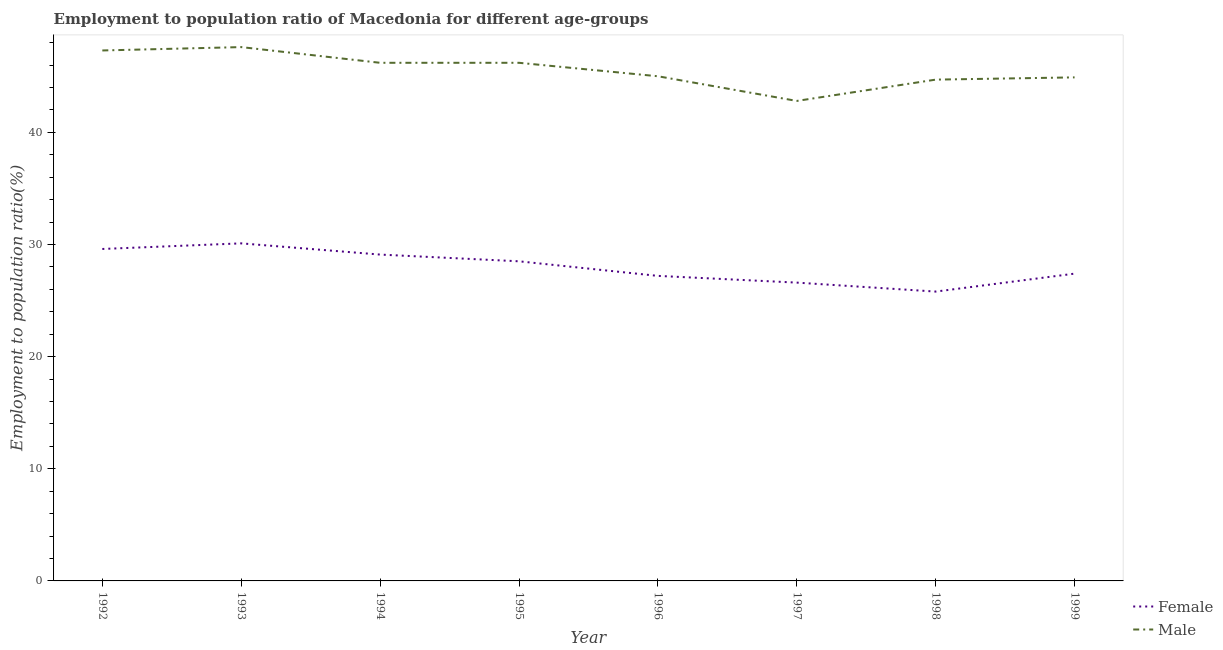How many different coloured lines are there?
Your answer should be very brief. 2. Does the line corresponding to employment to population ratio(female) intersect with the line corresponding to employment to population ratio(male)?
Your answer should be compact. No. Is the number of lines equal to the number of legend labels?
Give a very brief answer. Yes. What is the employment to population ratio(female) in 1992?
Your answer should be very brief. 29.6. Across all years, what is the maximum employment to population ratio(male)?
Provide a short and direct response. 47.6. Across all years, what is the minimum employment to population ratio(female)?
Provide a short and direct response. 25.8. In which year was the employment to population ratio(male) maximum?
Your response must be concise. 1993. In which year was the employment to population ratio(male) minimum?
Your answer should be very brief. 1997. What is the total employment to population ratio(male) in the graph?
Provide a succinct answer. 364.7. What is the difference between the employment to population ratio(male) in 1993 and that in 1997?
Your response must be concise. 4.8. What is the difference between the employment to population ratio(male) in 1997 and the employment to population ratio(female) in 1995?
Keep it short and to the point. 14.3. What is the average employment to population ratio(male) per year?
Your response must be concise. 45.59. In the year 1993, what is the difference between the employment to population ratio(female) and employment to population ratio(male)?
Offer a terse response. -17.5. What is the ratio of the employment to population ratio(male) in 1994 to that in 1996?
Your answer should be very brief. 1.03. Is the employment to population ratio(female) in 1992 less than that in 1999?
Provide a succinct answer. No. What is the difference between the highest and the second highest employment to population ratio(male)?
Your response must be concise. 0.3. What is the difference between the highest and the lowest employment to population ratio(male)?
Your answer should be compact. 4.8. Does the employment to population ratio(female) monotonically increase over the years?
Make the answer very short. No. Is the employment to population ratio(male) strictly greater than the employment to population ratio(female) over the years?
Offer a terse response. Yes. Is the employment to population ratio(male) strictly less than the employment to population ratio(female) over the years?
Offer a very short reply. No. How many lines are there?
Your response must be concise. 2. How many years are there in the graph?
Offer a very short reply. 8. Are the values on the major ticks of Y-axis written in scientific E-notation?
Keep it short and to the point. No. Where does the legend appear in the graph?
Provide a short and direct response. Bottom right. How many legend labels are there?
Give a very brief answer. 2. What is the title of the graph?
Make the answer very short. Employment to population ratio of Macedonia for different age-groups. What is the label or title of the X-axis?
Provide a short and direct response. Year. What is the Employment to population ratio(%) in Female in 1992?
Your answer should be compact. 29.6. What is the Employment to population ratio(%) in Male in 1992?
Provide a short and direct response. 47.3. What is the Employment to population ratio(%) in Female in 1993?
Ensure brevity in your answer.  30.1. What is the Employment to population ratio(%) of Male in 1993?
Make the answer very short. 47.6. What is the Employment to population ratio(%) of Female in 1994?
Your response must be concise. 29.1. What is the Employment to population ratio(%) in Male in 1994?
Your answer should be compact. 46.2. What is the Employment to population ratio(%) in Female in 1995?
Offer a very short reply. 28.5. What is the Employment to population ratio(%) of Male in 1995?
Provide a short and direct response. 46.2. What is the Employment to population ratio(%) in Female in 1996?
Your response must be concise. 27.2. What is the Employment to population ratio(%) in Male in 1996?
Provide a succinct answer. 45. What is the Employment to population ratio(%) of Female in 1997?
Make the answer very short. 26.6. What is the Employment to population ratio(%) of Male in 1997?
Provide a short and direct response. 42.8. What is the Employment to population ratio(%) in Female in 1998?
Your answer should be compact. 25.8. What is the Employment to population ratio(%) in Male in 1998?
Your response must be concise. 44.7. What is the Employment to population ratio(%) of Female in 1999?
Give a very brief answer. 27.4. What is the Employment to population ratio(%) of Male in 1999?
Ensure brevity in your answer.  44.9. Across all years, what is the maximum Employment to population ratio(%) of Female?
Your answer should be very brief. 30.1. Across all years, what is the maximum Employment to population ratio(%) in Male?
Make the answer very short. 47.6. Across all years, what is the minimum Employment to population ratio(%) of Female?
Keep it short and to the point. 25.8. Across all years, what is the minimum Employment to population ratio(%) in Male?
Your answer should be very brief. 42.8. What is the total Employment to population ratio(%) in Female in the graph?
Ensure brevity in your answer.  224.3. What is the total Employment to population ratio(%) of Male in the graph?
Keep it short and to the point. 364.7. What is the difference between the Employment to population ratio(%) of Male in 1992 and that in 1993?
Your response must be concise. -0.3. What is the difference between the Employment to population ratio(%) of Male in 1992 and that in 1995?
Your answer should be very brief. 1.1. What is the difference between the Employment to population ratio(%) of Male in 1992 and that in 1996?
Your answer should be very brief. 2.3. What is the difference between the Employment to population ratio(%) of Female in 1992 and that in 1997?
Offer a terse response. 3. What is the difference between the Employment to population ratio(%) of Female in 1992 and that in 1998?
Keep it short and to the point. 3.8. What is the difference between the Employment to population ratio(%) of Female in 1992 and that in 1999?
Keep it short and to the point. 2.2. What is the difference between the Employment to population ratio(%) in Male in 1992 and that in 1999?
Your answer should be compact. 2.4. What is the difference between the Employment to population ratio(%) of Male in 1993 and that in 1995?
Make the answer very short. 1.4. What is the difference between the Employment to population ratio(%) of Female in 1993 and that in 1996?
Make the answer very short. 2.9. What is the difference between the Employment to population ratio(%) of Male in 1993 and that in 1996?
Keep it short and to the point. 2.6. What is the difference between the Employment to population ratio(%) in Male in 1993 and that in 1997?
Your response must be concise. 4.8. What is the difference between the Employment to population ratio(%) of Female in 1993 and that in 1999?
Your response must be concise. 2.7. What is the difference between the Employment to population ratio(%) of Male in 1993 and that in 1999?
Make the answer very short. 2.7. What is the difference between the Employment to population ratio(%) of Male in 1994 and that in 1996?
Provide a short and direct response. 1.2. What is the difference between the Employment to population ratio(%) of Female in 1994 and that in 1997?
Make the answer very short. 2.5. What is the difference between the Employment to population ratio(%) of Female in 1994 and that in 1998?
Give a very brief answer. 3.3. What is the difference between the Employment to population ratio(%) in Female in 1995 and that in 1996?
Your response must be concise. 1.3. What is the difference between the Employment to population ratio(%) in Male in 1995 and that in 1998?
Make the answer very short. 1.5. What is the difference between the Employment to population ratio(%) in Male in 1995 and that in 1999?
Offer a terse response. 1.3. What is the difference between the Employment to population ratio(%) of Female in 1996 and that in 1997?
Make the answer very short. 0.6. What is the difference between the Employment to population ratio(%) in Male in 1996 and that in 1998?
Your answer should be very brief. 0.3. What is the difference between the Employment to population ratio(%) of Male in 1996 and that in 1999?
Your answer should be very brief. 0.1. What is the difference between the Employment to population ratio(%) in Male in 1997 and that in 1999?
Ensure brevity in your answer.  -2.1. What is the difference between the Employment to population ratio(%) in Female in 1992 and the Employment to population ratio(%) in Male in 1993?
Keep it short and to the point. -18. What is the difference between the Employment to population ratio(%) in Female in 1992 and the Employment to population ratio(%) in Male in 1994?
Your answer should be very brief. -16.6. What is the difference between the Employment to population ratio(%) of Female in 1992 and the Employment to population ratio(%) of Male in 1995?
Your response must be concise. -16.6. What is the difference between the Employment to population ratio(%) of Female in 1992 and the Employment to population ratio(%) of Male in 1996?
Keep it short and to the point. -15.4. What is the difference between the Employment to population ratio(%) of Female in 1992 and the Employment to population ratio(%) of Male in 1997?
Provide a short and direct response. -13.2. What is the difference between the Employment to population ratio(%) in Female in 1992 and the Employment to population ratio(%) in Male in 1998?
Your response must be concise. -15.1. What is the difference between the Employment to population ratio(%) in Female in 1992 and the Employment to population ratio(%) in Male in 1999?
Give a very brief answer. -15.3. What is the difference between the Employment to population ratio(%) in Female in 1993 and the Employment to population ratio(%) in Male in 1994?
Make the answer very short. -16.1. What is the difference between the Employment to population ratio(%) of Female in 1993 and the Employment to population ratio(%) of Male in 1995?
Offer a terse response. -16.1. What is the difference between the Employment to population ratio(%) of Female in 1993 and the Employment to population ratio(%) of Male in 1996?
Ensure brevity in your answer.  -14.9. What is the difference between the Employment to population ratio(%) in Female in 1993 and the Employment to population ratio(%) in Male in 1997?
Your answer should be compact. -12.7. What is the difference between the Employment to population ratio(%) in Female in 1993 and the Employment to population ratio(%) in Male in 1998?
Your answer should be compact. -14.6. What is the difference between the Employment to population ratio(%) of Female in 1993 and the Employment to population ratio(%) of Male in 1999?
Ensure brevity in your answer.  -14.8. What is the difference between the Employment to population ratio(%) in Female in 1994 and the Employment to population ratio(%) in Male in 1995?
Provide a succinct answer. -17.1. What is the difference between the Employment to population ratio(%) in Female in 1994 and the Employment to population ratio(%) in Male in 1996?
Ensure brevity in your answer.  -15.9. What is the difference between the Employment to population ratio(%) of Female in 1994 and the Employment to population ratio(%) of Male in 1997?
Your answer should be very brief. -13.7. What is the difference between the Employment to population ratio(%) in Female in 1994 and the Employment to population ratio(%) in Male in 1998?
Keep it short and to the point. -15.6. What is the difference between the Employment to population ratio(%) of Female in 1994 and the Employment to population ratio(%) of Male in 1999?
Your answer should be very brief. -15.8. What is the difference between the Employment to population ratio(%) of Female in 1995 and the Employment to population ratio(%) of Male in 1996?
Give a very brief answer. -16.5. What is the difference between the Employment to population ratio(%) in Female in 1995 and the Employment to population ratio(%) in Male in 1997?
Provide a succinct answer. -14.3. What is the difference between the Employment to population ratio(%) in Female in 1995 and the Employment to population ratio(%) in Male in 1998?
Make the answer very short. -16.2. What is the difference between the Employment to population ratio(%) of Female in 1995 and the Employment to population ratio(%) of Male in 1999?
Your answer should be very brief. -16.4. What is the difference between the Employment to population ratio(%) in Female in 1996 and the Employment to population ratio(%) in Male in 1997?
Your response must be concise. -15.6. What is the difference between the Employment to population ratio(%) in Female in 1996 and the Employment to population ratio(%) in Male in 1998?
Keep it short and to the point. -17.5. What is the difference between the Employment to population ratio(%) in Female in 1996 and the Employment to population ratio(%) in Male in 1999?
Provide a succinct answer. -17.7. What is the difference between the Employment to population ratio(%) of Female in 1997 and the Employment to population ratio(%) of Male in 1998?
Your answer should be very brief. -18.1. What is the difference between the Employment to population ratio(%) in Female in 1997 and the Employment to population ratio(%) in Male in 1999?
Offer a terse response. -18.3. What is the difference between the Employment to population ratio(%) of Female in 1998 and the Employment to population ratio(%) of Male in 1999?
Provide a short and direct response. -19.1. What is the average Employment to population ratio(%) of Female per year?
Provide a succinct answer. 28.04. What is the average Employment to population ratio(%) of Male per year?
Make the answer very short. 45.59. In the year 1992, what is the difference between the Employment to population ratio(%) of Female and Employment to population ratio(%) of Male?
Your answer should be very brief. -17.7. In the year 1993, what is the difference between the Employment to population ratio(%) in Female and Employment to population ratio(%) in Male?
Offer a terse response. -17.5. In the year 1994, what is the difference between the Employment to population ratio(%) of Female and Employment to population ratio(%) of Male?
Make the answer very short. -17.1. In the year 1995, what is the difference between the Employment to population ratio(%) of Female and Employment to population ratio(%) of Male?
Ensure brevity in your answer.  -17.7. In the year 1996, what is the difference between the Employment to population ratio(%) of Female and Employment to population ratio(%) of Male?
Provide a succinct answer. -17.8. In the year 1997, what is the difference between the Employment to population ratio(%) in Female and Employment to population ratio(%) in Male?
Your response must be concise. -16.2. In the year 1998, what is the difference between the Employment to population ratio(%) of Female and Employment to population ratio(%) of Male?
Provide a short and direct response. -18.9. In the year 1999, what is the difference between the Employment to population ratio(%) in Female and Employment to population ratio(%) in Male?
Offer a very short reply. -17.5. What is the ratio of the Employment to population ratio(%) in Female in 1992 to that in 1993?
Your answer should be very brief. 0.98. What is the ratio of the Employment to population ratio(%) in Female in 1992 to that in 1994?
Your response must be concise. 1.02. What is the ratio of the Employment to population ratio(%) of Male in 1992 to that in 1994?
Your response must be concise. 1.02. What is the ratio of the Employment to population ratio(%) in Female in 1992 to that in 1995?
Your response must be concise. 1.04. What is the ratio of the Employment to population ratio(%) of Male in 1992 to that in 1995?
Provide a succinct answer. 1.02. What is the ratio of the Employment to population ratio(%) in Female in 1992 to that in 1996?
Offer a terse response. 1.09. What is the ratio of the Employment to population ratio(%) of Male in 1992 to that in 1996?
Provide a succinct answer. 1.05. What is the ratio of the Employment to population ratio(%) in Female in 1992 to that in 1997?
Your response must be concise. 1.11. What is the ratio of the Employment to population ratio(%) in Male in 1992 to that in 1997?
Provide a succinct answer. 1.11. What is the ratio of the Employment to population ratio(%) in Female in 1992 to that in 1998?
Your answer should be very brief. 1.15. What is the ratio of the Employment to population ratio(%) of Male in 1992 to that in 1998?
Offer a terse response. 1.06. What is the ratio of the Employment to population ratio(%) of Female in 1992 to that in 1999?
Offer a terse response. 1.08. What is the ratio of the Employment to population ratio(%) of Male in 1992 to that in 1999?
Make the answer very short. 1.05. What is the ratio of the Employment to population ratio(%) of Female in 1993 to that in 1994?
Offer a terse response. 1.03. What is the ratio of the Employment to population ratio(%) in Male in 1993 to that in 1994?
Make the answer very short. 1.03. What is the ratio of the Employment to population ratio(%) of Female in 1993 to that in 1995?
Ensure brevity in your answer.  1.06. What is the ratio of the Employment to population ratio(%) in Male in 1993 to that in 1995?
Ensure brevity in your answer.  1.03. What is the ratio of the Employment to population ratio(%) in Female in 1993 to that in 1996?
Keep it short and to the point. 1.11. What is the ratio of the Employment to population ratio(%) in Male in 1993 to that in 1996?
Ensure brevity in your answer.  1.06. What is the ratio of the Employment to population ratio(%) in Female in 1993 to that in 1997?
Your response must be concise. 1.13. What is the ratio of the Employment to population ratio(%) in Male in 1993 to that in 1997?
Keep it short and to the point. 1.11. What is the ratio of the Employment to population ratio(%) in Male in 1993 to that in 1998?
Your answer should be very brief. 1.06. What is the ratio of the Employment to population ratio(%) of Female in 1993 to that in 1999?
Ensure brevity in your answer.  1.1. What is the ratio of the Employment to population ratio(%) in Male in 1993 to that in 1999?
Provide a short and direct response. 1.06. What is the ratio of the Employment to population ratio(%) of Female in 1994 to that in 1995?
Keep it short and to the point. 1.02. What is the ratio of the Employment to population ratio(%) in Female in 1994 to that in 1996?
Provide a short and direct response. 1.07. What is the ratio of the Employment to population ratio(%) of Male in 1994 to that in 1996?
Provide a succinct answer. 1.03. What is the ratio of the Employment to population ratio(%) of Female in 1994 to that in 1997?
Offer a terse response. 1.09. What is the ratio of the Employment to population ratio(%) of Male in 1994 to that in 1997?
Keep it short and to the point. 1.08. What is the ratio of the Employment to population ratio(%) of Female in 1994 to that in 1998?
Your answer should be very brief. 1.13. What is the ratio of the Employment to population ratio(%) in Male in 1994 to that in 1998?
Make the answer very short. 1.03. What is the ratio of the Employment to population ratio(%) in Female in 1994 to that in 1999?
Make the answer very short. 1.06. What is the ratio of the Employment to population ratio(%) of Female in 1995 to that in 1996?
Give a very brief answer. 1.05. What is the ratio of the Employment to population ratio(%) in Male in 1995 to that in 1996?
Provide a short and direct response. 1.03. What is the ratio of the Employment to population ratio(%) in Female in 1995 to that in 1997?
Your answer should be compact. 1.07. What is the ratio of the Employment to population ratio(%) of Male in 1995 to that in 1997?
Your answer should be compact. 1.08. What is the ratio of the Employment to population ratio(%) in Female in 1995 to that in 1998?
Provide a short and direct response. 1.1. What is the ratio of the Employment to population ratio(%) in Male in 1995 to that in 1998?
Your answer should be very brief. 1.03. What is the ratio of the Employment to population ratio(%) of Female in 1995 to that in 1999?
Your response must be concise. 1.04. What is the ratio of the Employment to population ratio(%) of Male in 1995 to that in 1999?
Your response must be concise. 1.03. What is the ratio of the Employment to population ratio(%) of Female in 1996 to that in 1997?
Offer a terse response. 1.02. What is the ratio of the Employment to population ratio(%) in Male in 1996 to that in 1997?
Make the answer very short. 1.05. What is the ratio of the Employment to population ratio(%) in Female in 1996 to that in 1998?
Give a very brief answer. 1.05. What is the ratio of the Employment to population ratio(%) in Male in 1996 to that in 1998?
Keep it short and to the point. 1.01. What is the ratio of the Employment to population ratio(%) in Female in 1996 to that in 1999?
Offer a terse response. 0.99. What is the ratio of the Employment to population ratio(%) in Female in 1997 to that in 1998?
Keep it short and to the point. 1.03. What is the ratio of the Employment to population ratio(%) in Male in 1997 to that in 1998?
Your answer should be compact. 0.96. What is the ratio of the Employment to population ratio(%) of Female in 1997 to that in 1999?
Ensure brevity in your answer.  0.97. What is the ratio of the Employment to population ratio(%) of Male in 1997 to that in 1999?
Offer a terse response. 0.95. What is the ratio of the Employment to population ratio(%) in Female in 1998 to that in 1999?
Provide a short and direct response. 0.94. What is the ratio of the Employment to population ratio(%) of Male in 1998 to that in 1999?
Your answer should be very brief. 1. What is the difference between the highest and the lowest Employment to population ratio(%) in Female?
Your answer should be very brief. 4.3. 